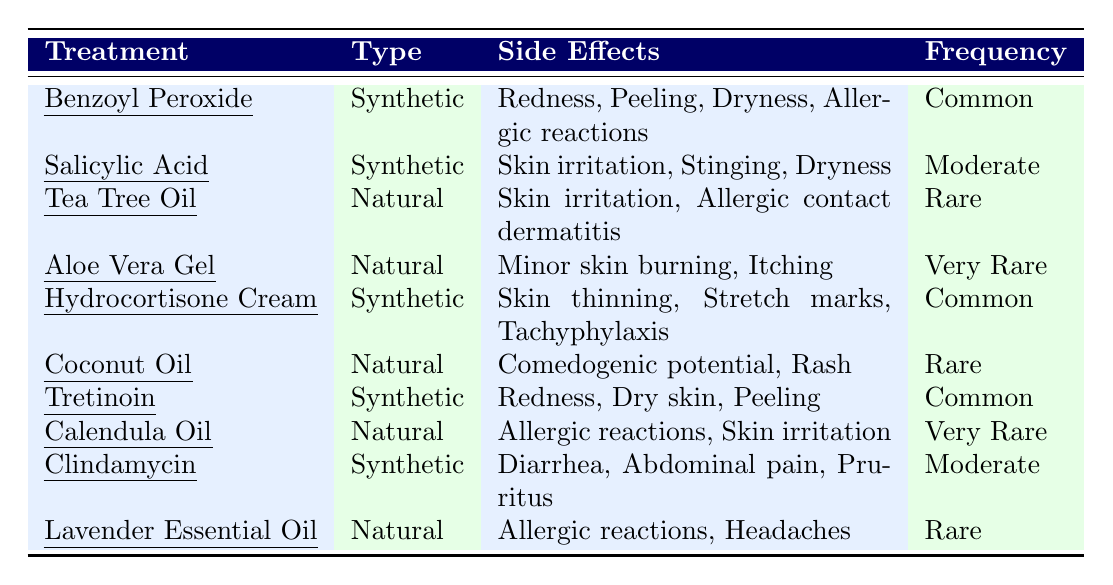What are the side effects of Tretinoin? According to the table, Tretinoin has side effects listed as Redness, Dry skin, and Peeling.
Answer: Redness, Dry skin, Peeling Which treatment has the most common side effects? The table shows that Benzoyl Peroxide, Hydrocortisone Cream, and Tretinoin all have a "Common" frequency of side effects.
Answer: Benzoyl Peroxide, Hydrocortisone Cream, Tretinoin Is Aloe Vera Gel associated with common side effects? The table indicates that Aloe Vera Gel has a frequency categorized as "Very Rare," which correlates with fewer occurrences of side effects rather than common ones.
Answer: No What is the frequency of side effects for Coconut Oil? The frequency listed for Coconut Oil in the table is "Rare."
Answer: Rare How many natural treatments have side effects categorized as "Very Rare"? The table lists two natural treatments—Aloe Vera Gel and Calendula Oil—with side effects categorized as "Very Rare." This indicates a total of two treatments.
Answer: 2 Which synthetic treatment has the lowest frequency of side effects? Both Salicylic Acid and Clindamycin have a frequency classified as "Moderate," while no synthetic treatment is categorized as having "Rare" or "Very Rare" frequency, establishing that Salicylic Acid and Clindamycin have the lowest frequency compared to more common side effects.
Answer: Salicylic Acid and Clindamycin Do any natural treatments have side effects that are classified as common? The table does not list any natural treatments with side effects classified as "Common," as the highest frequency for natural treatments is "Rare." Therefore, the answer must be no.
Answer: No Which type of treatment generally has more side effects according to the table? By reviewing the listed side effects for both synthetic and natural treatments, synthetic treatments have multiple side effects categorized as common or moderate. In contrast, natural treatments primarily have side effects classified as rare. Thus, synthetic treatments have more overall side effects.
Answer: Synthetic treatments What is the combined frequency of side effects for all natural treatments? The natural treatments reported frequencies of "Rare" for Tea Tree Oil, Coconut Oil, and Lavender Essential Oil, and "Very Rare" for Aloe Vera Gel and Calendula Oil. Therefore, the combined frequency shows a predominance of rare instances.
Answer: Predominantly Rare 